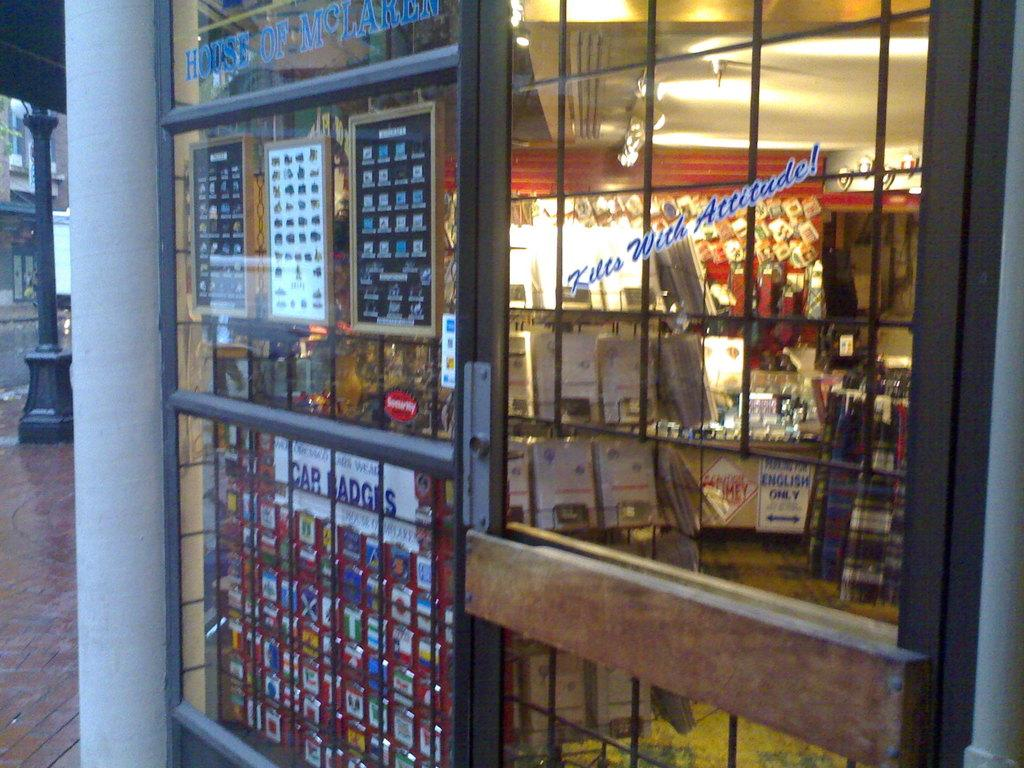<image>
Share a concise interpretation of the image provided. The storefront for Kilts with Attitude is shown. 